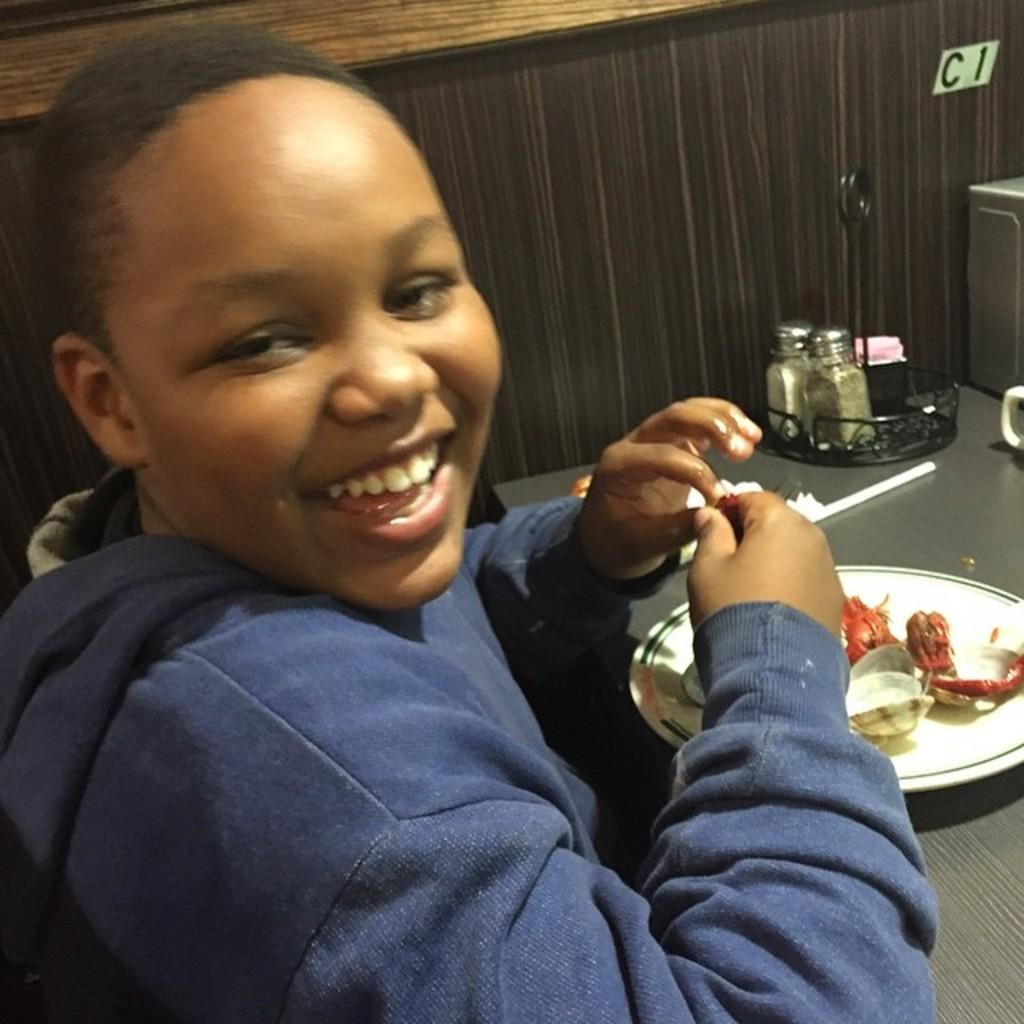What is the boy doing in the image? The boy is sitting on a chair in the image. What can be seen on the table in the image? There are eatable items placed on a table in the image. How does the boy stop the spade from digging in the image? There is no spade or digging activity present in the image. 